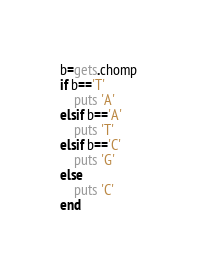<code> <loc_0><loc_0><loc_500><loc_500><_Ruby_>b=gets.chomp
if b=='T'
    puts 'A'
elsif b=='A'
    puts 'T'
elsif b=='C'
    puts 'G'
else
    puts 'C'
end</code> 